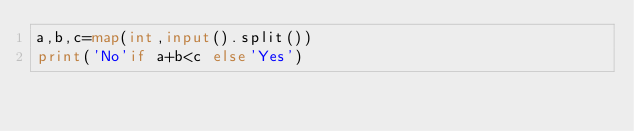Convert code to text. <code><loc_0><loc_0><loc_500><loc_500><_Python_>a,b,c=map(int,input().split())
print('No'if a+b<c else'Yes')</code> 